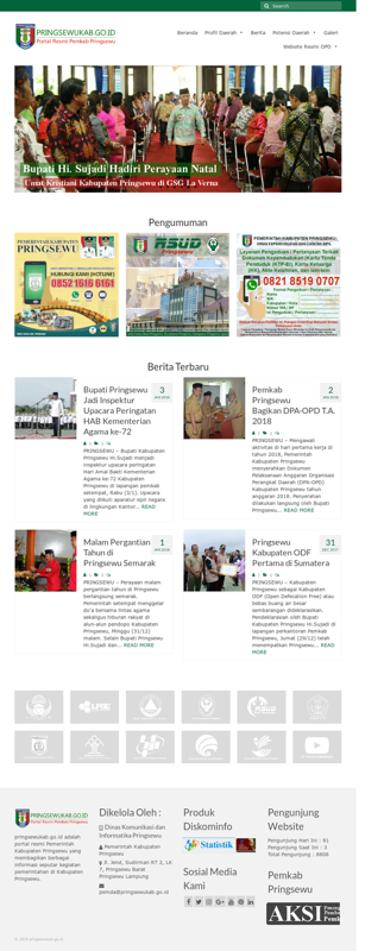What is one of the news headlines on the website? An intriguing headline featured on the site reads: “Bupati Hi Sujadi Hadiri Perayaan Natal diGsG1aVerm.” This highlights an event where Bupati Hi Sujadi attended a Christmas celebration, although the ending part of the headline seems to contain either a typographical error or a formatting issue. 